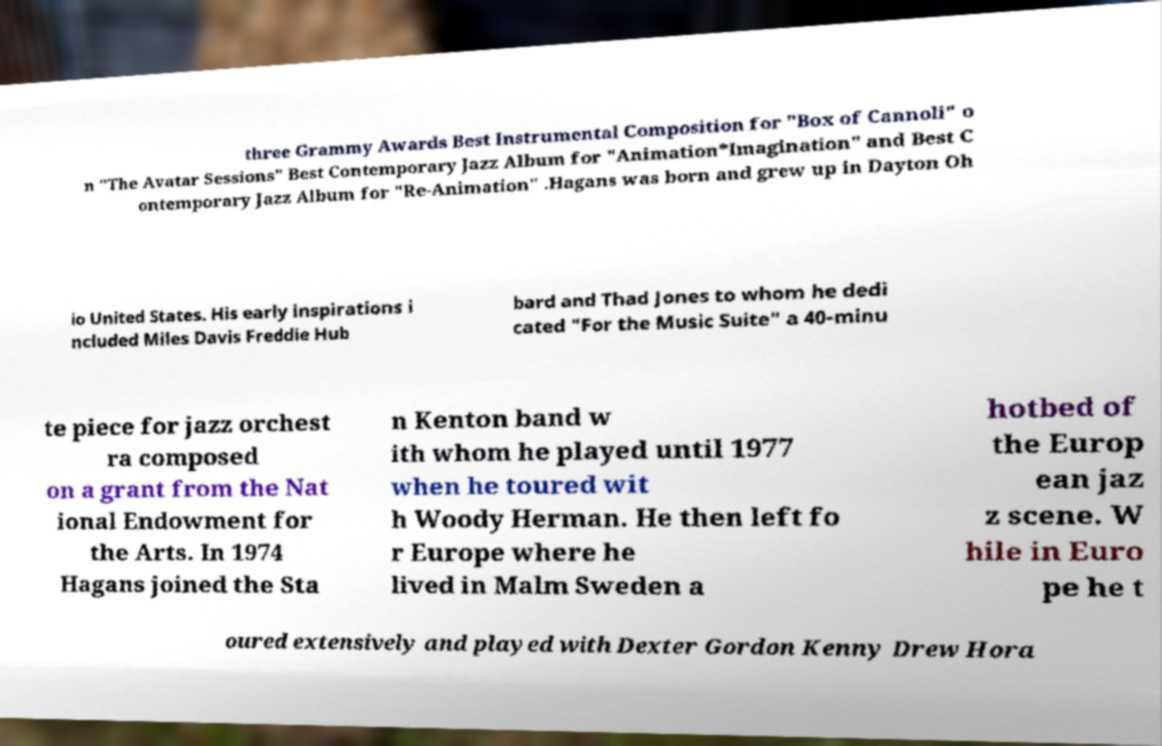I need the written content from this picture converted into text. Can you do that? three Grammy Awards Best Instrumental Composition for "Box of Cannoli" o n "The Avatar Sessions" Best Contemporary Jazz Album for "Animation*Imagination" and Best C ontemporary Jazz Album for "Re-Animation" .Hagans was born and grew up in Dayton Oh io United States. His early inspirations i ncluded Miles Davis Freddie Hub bard and Thad Jones to whom he dedi cated "For the Music Suite" a 40-minu te piece for jazz orchest ra composed on a grant from the Nat ional Endowment for the Arts. In 1974 Hagans joined the Sta n Kenton band w ith whom he played until 1977 when he toured wit h Woody Herman. He then left fo r Europe where he lived in Malm Sweden a hotbed of the Europ ean jaz z scene. W hile in Euro pe he t oured extensively and played with Dexter Gordon Kenny Drew Hora 